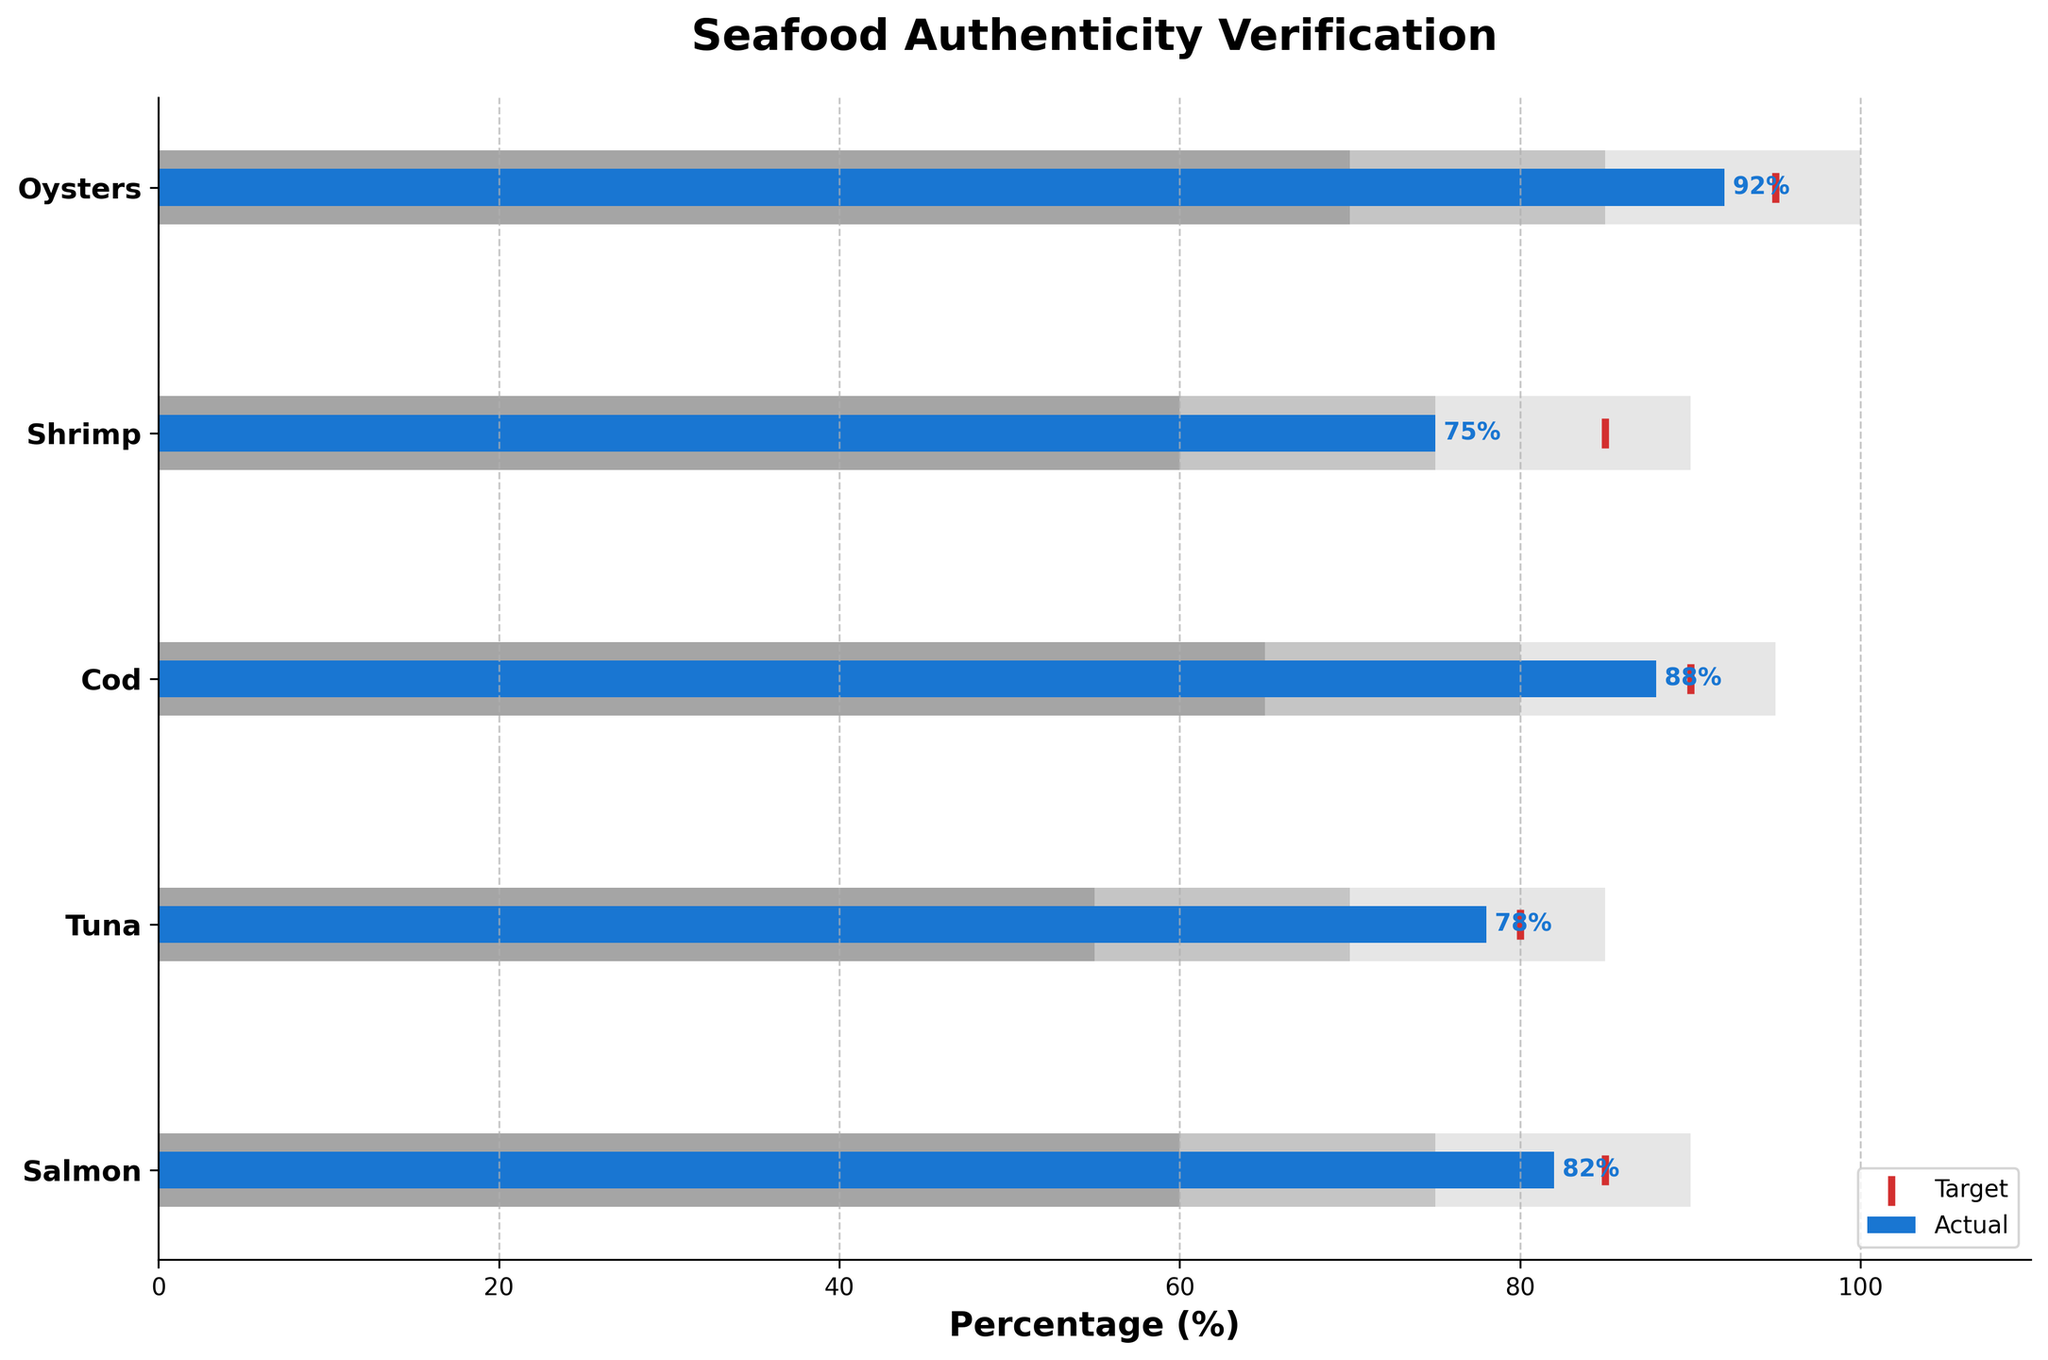What is the title of the chart? The title is always prominently displayed at the top of the chart and provides the main context for what the chart represents. In this case, it reads "Seafood Authenticity Verification".
Answer: Seafood Authenticity Verification Which seafood category has the highest percentage of authenticity verification? To determine which seafood category has the highest percentage, look for the category with the highest bar in the "Actual" values. Here, Oysters have the highest authenticity verification percentage of 92%.
Answer: Oysters What range does the gray bar represent? The three shades of gray represent different ranges. The darkest gray represents Range1, the medium gray represents Range2, and the lightest gray represents Range3.
Answer: Different percentage ranges for authenticity verification How does the actual percentage of Shrimp compare to its target? For Shrimp, look at the blue bar for the actual percentage and the red marker for the target. The actual percentage of Shrimp is 75%, while the target is 85%. The actual percentage is 10% below the target.
Answer: 10% below target Which seafood category came closest to meeting its target? To find the category closest to its target, compare the gap between the actual (blue bars) and target (red markers) for each category. Cod has an actual of 88% and a target of 90%, making it only 2% below its target, the smallest gap among all categories.
Answer: Cod How many seafood categories met or exceeded the 'Range2' threshold? 'Range2' for each category is shown in medium gray. Compare the blue actual bars to these 'Range2' thresholds. For Salmon, Tuna, Cod, and Shrimp, the blue bars meet or exceed their respective 'Range2' minimum thresholds. Hence, 4 categories meet or exceed 'Range2'.
Answer: 4 categories What is the average target percentage across all seafood categories? To calculate the average target percentage, sum the target percentages for all categories and divide by the number of categories: (85 + 80 + 90 + 85 + 95) / 5 = 87%.
Answer: 87% Which category has the smallest margin between the 'Actual' and 'Range3' value? Compare the differences between the actual values (blue bars) and the limits of 'Range3' (light gray) for each category. Shrimp has the smallest margin since its actual is 75% and 'Range3' is 90%, making a difference of 15%.
Answer: Shrimp What color is used to depict the target values in the chart? The target values are highlighted using the red scatter markers lined along the y-axis on the chart.
Answer: Red Is any seafood category's actual percentage within its 'Range3'? Check to see if any blue bars fall within the lightest gray bars (Range3). All categories have their actual percentages within their respective 'Range3'.
Answer: Yes 